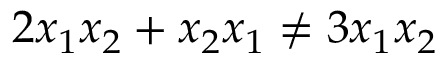Convert formula to latex. <formula><loc_0><loc_0><loc_500><loc_500>2 x _ { 1 } x _ { 2 } + x _ { 2 } x _ { 1 } \neq 3 x _ { 1 } x _ { 2 }</formula> 